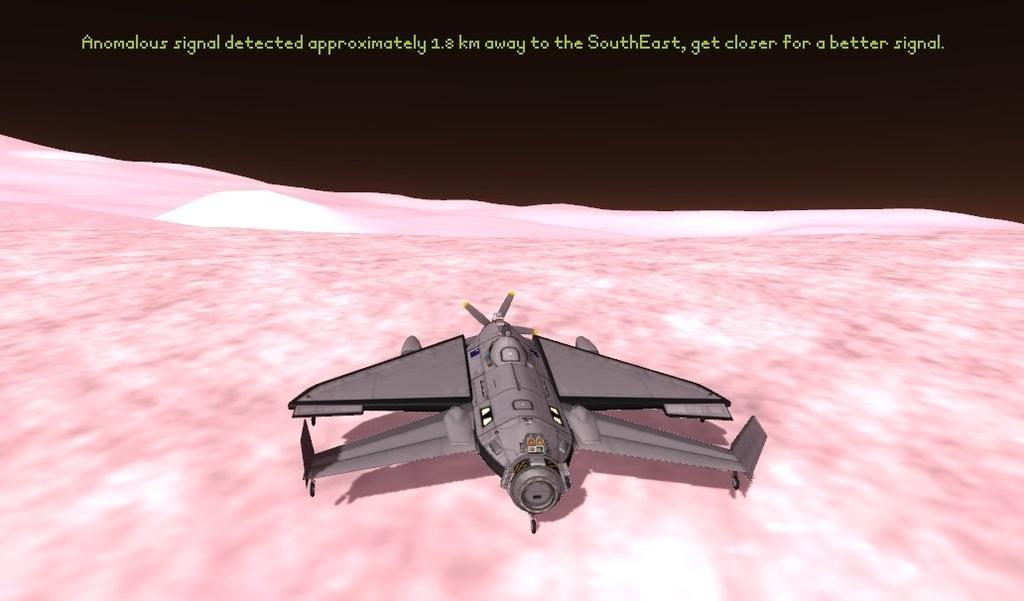Can you describe this image briefly? This is an animated image. In this image we can see a rocket and text at the top. 